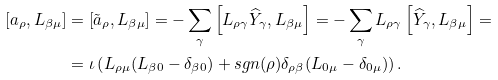Convert formula to latex. <formula><loc_0><loc_0><loc_500><loc_500>\left [ a _ { \rho } , L _ { \beta \mu } \right ] & = \left [ \tilde { a } _ { \rho } , L _ { \beta \mu } \right ] = - \sum _ { \gamma } \left [ L _ { \rho \gamma } \widehat { Y } _ { \gamma } , L _ { \beta \mu } \right ] = - \sum _ { \gamma } L _ { \rho \gamma } \left [ \widehat { Y } _ { \gamma } , L _ { \beta \mu } \right ] = \\ & = \iota \left ( L _ { \rho \mu } ( L _ { \beta 0 } - \delta _ { \beta 0 } ) + s g n ( \rho ) \delta _ { \rho \beta } ( L _ { 0 \mu } - \delta _ { 0 \mu } ) \right ) .</formula> 